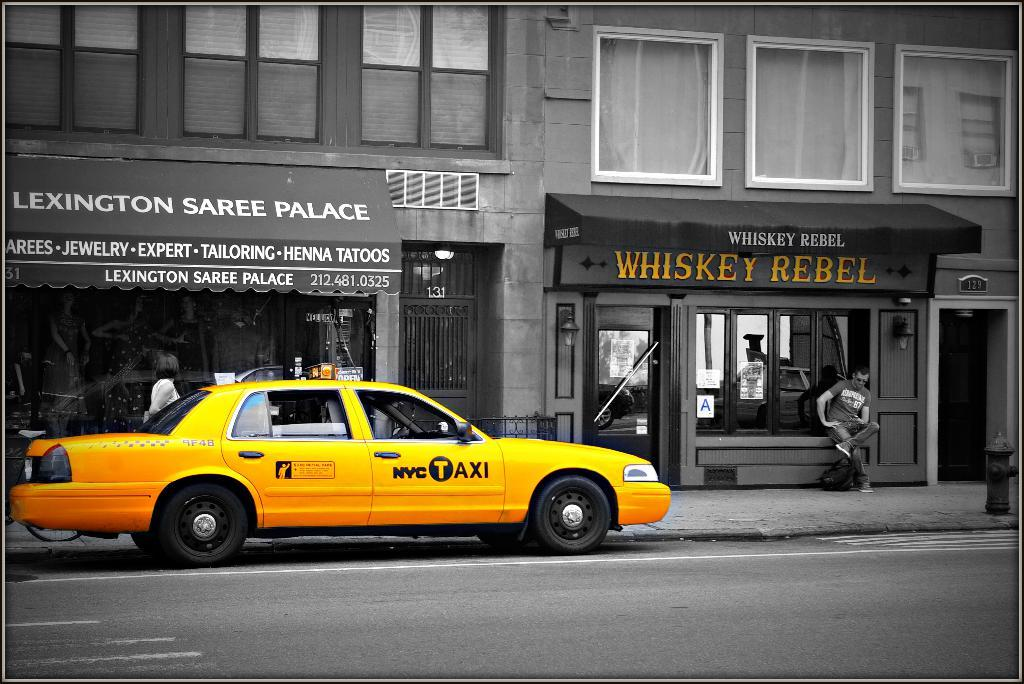<image>
Describe the image concisely. A taxi parked in front of Lexington Saree Palace. 